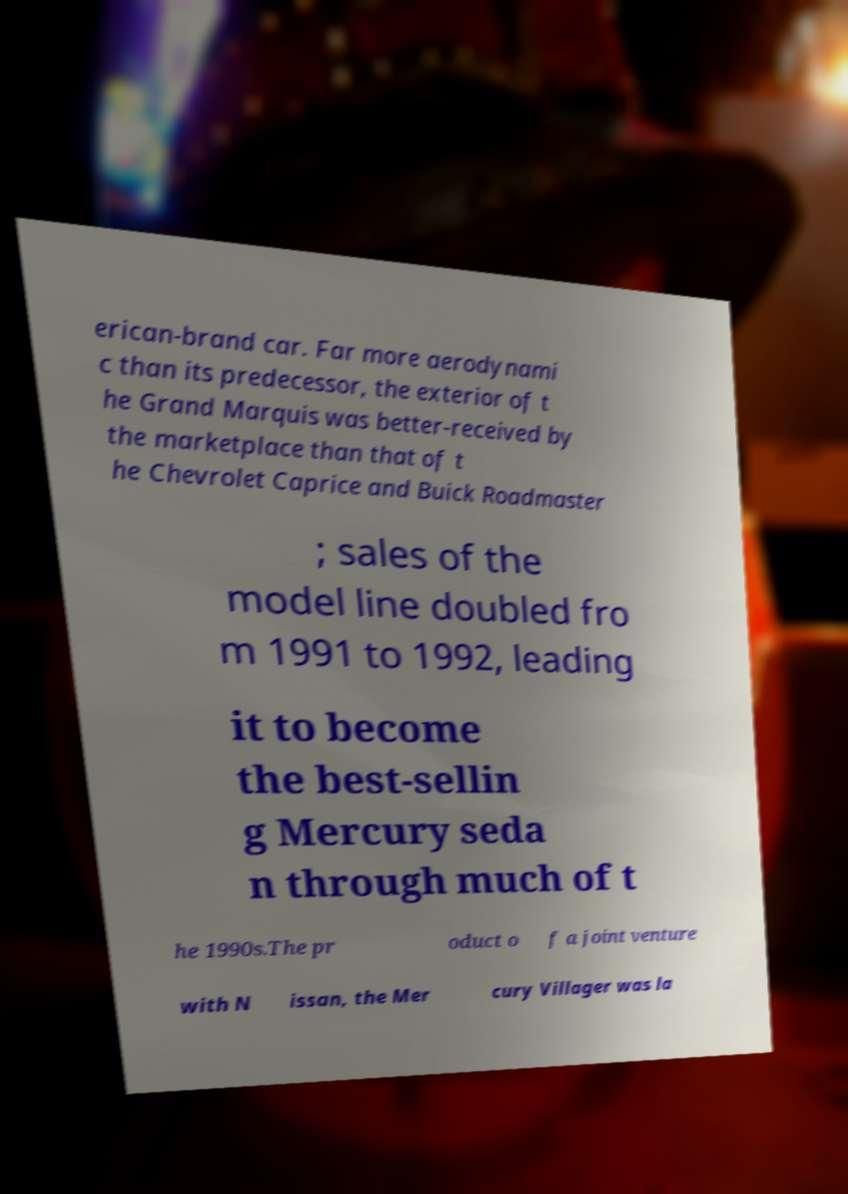There's text embedded in this image that I need extracted. Can you transcribe it verbatim? erican-brand car. Far more aerodynami c than its predecessor, the exterior of t he Grand Marquis was better-received by the marketplace than that of t he Chevrolet Caprice and Buick Roadmaster ; sales of the model line doubled fro m 1991 to 1992, leading it to become the best-sellin g Mercury seda n through much of t he 1990s.The pr oduct o f a joint venture with N issan, the Mer cury Villager was la 